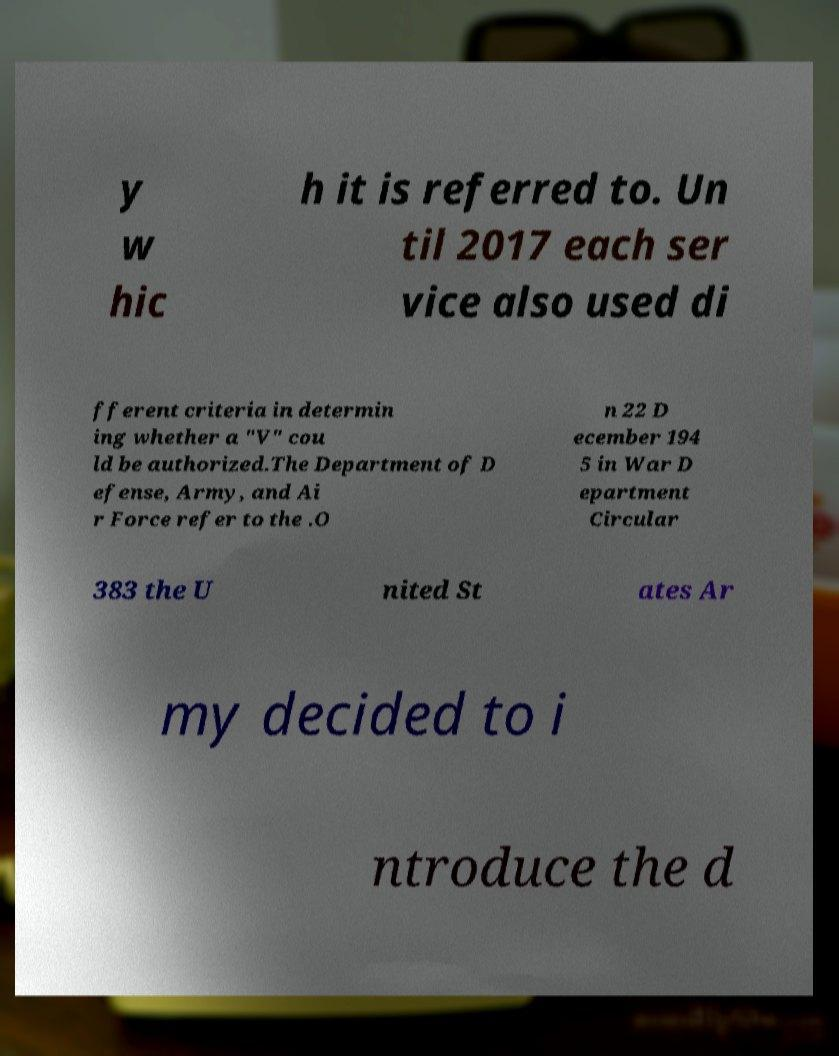For documentation purposes, I need the text within this image transcribed. Could you provide that? y w hic h it is referred to. Un til 2017 each ser vice also used di fferent criteria in determin ing whether a "V" cou ld be authorized.The Department of D efense, Army, and Ai r Force refer to the .O n 22 D ecember 194 5 in War D epartment Circular 383 the U nited St ates Ar my decided to i ntroduce the d 